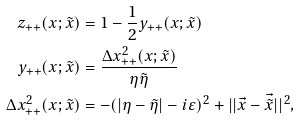<formula> <loc_0><loc_0><loc_500><loc_500>z _ { + + } ( x ; \tilde { x } ) & = 1 - \frac { 1 } { 2 } y _ { + + } ( x ; \tilde { x } ) \\ y _ { + + } ( x ; \tilde { x } ) & = \frac { \Delta x _ { + + } ^ { 2 } ( x ; \tilde { x } ) } { \eta \tilde { \eta } } \\ \Delta x _ { + + } ^ { 2 } ( x ; \tilde { x } ) & = - ( | \eta - \tilde { \eta } | - i \varepsilon ) ^ { 2 } + | | \vec { x } - \vec { \tilde { x } } | | ^ { 2 } ,</formula> 